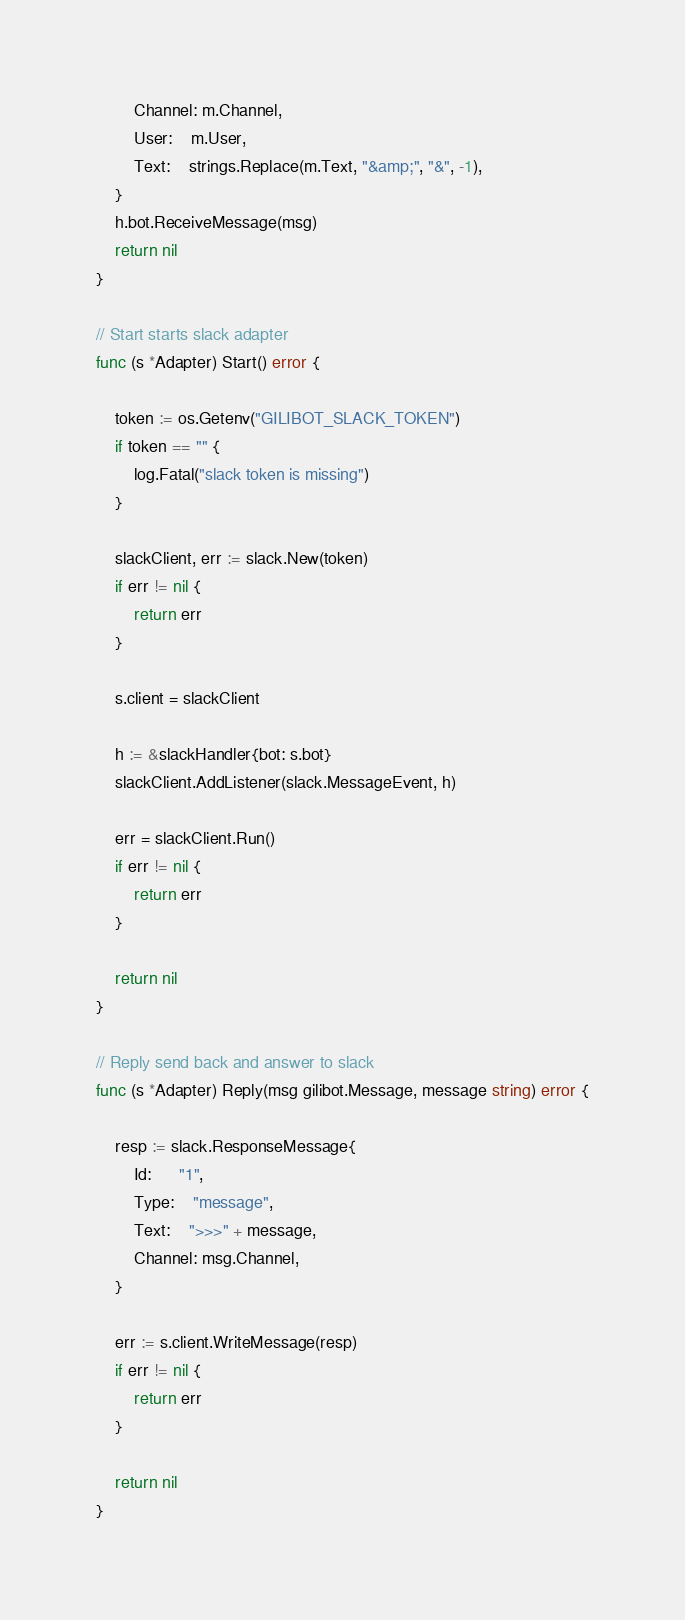<code> <loc_0><loc_0><loc_500><loc_500><_Go_>		Channel: m.Channel,
		User:    m.User,
		Text:    strings.Replace(m.Text, "&amp;", "&", -1),
	}
	h.bot.ReceiveMessage(msg)
	return nil
}

// Start starts slack adapter
func (s *Adapter) Start() error {

	token := os.Getenv("GILIBOT_SLACK_TOKEN")
	if token == "" {
		log.Fatal("slack token is missing")
	}

	slackClient, err := slack.New(token)
	if err != nil {
		return err
	}

	s.client = slackClient

	h := &slackHandler{bot: s.bot}
	slackClient.AddListener(slack.MessageEvent, h)

	err = slackClient.Run()
	if err != nil {
		return err
	}

	return nil
}

// Reply send back and answer to slack
func (s *Adapter) Reply(msg gilibot.Message, message string) error {

	resp := slack.ResponseMessage{
		Id:      "1",
		Type:    "message",
		Text:    ">>>" + message,
		Channel: msg.Channel,
	}

	err := s.client.WriteMessage(resp)
	if err != nil {
		return err
	}

	return nil
}
</code> 